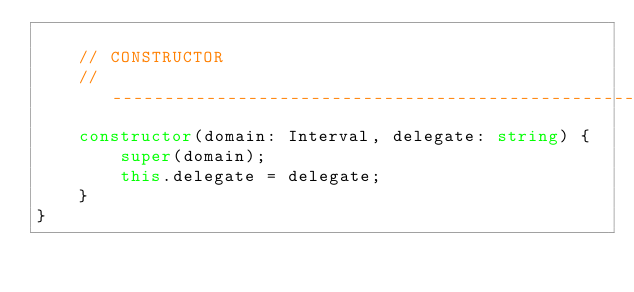Convert code to text. <code><loc_0><loc_0><loc_500><loc_500><_TypeScript_>
    // CONSTRUCTOR
    // --------------------------------------------------------------------------------------------
    constructor(domain: Interval, delegate: string) {
        super(domain);
        this.delegate = delegate;
    }
}</code> 